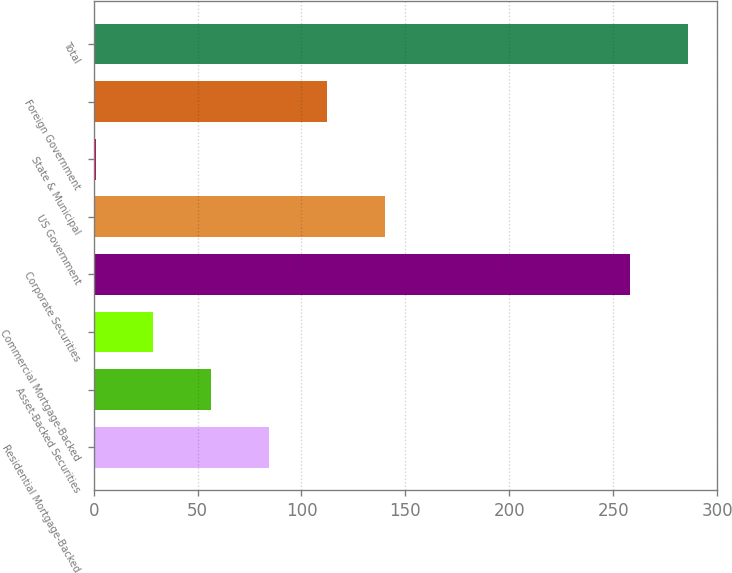Convert chart to OTSL. <chart><loc_0><loc_0><loc_500><loc_500><bar_chart><fcel>Residential Mortgage-Backed<fcel>Asset-Backed Securities<fcel>Commercial Mortgage-Backed<fcel>Corporate Securities<fcel>US Government<fcel>State & Municipal<fcel>Foreign Government<fcel>Total<nl><fcel>84.4<fcel>56.6<fcel>28.8<fcel>258<fcel>140<fcel>1<fcel>112.2<fcel>285.8<nl></chart> 